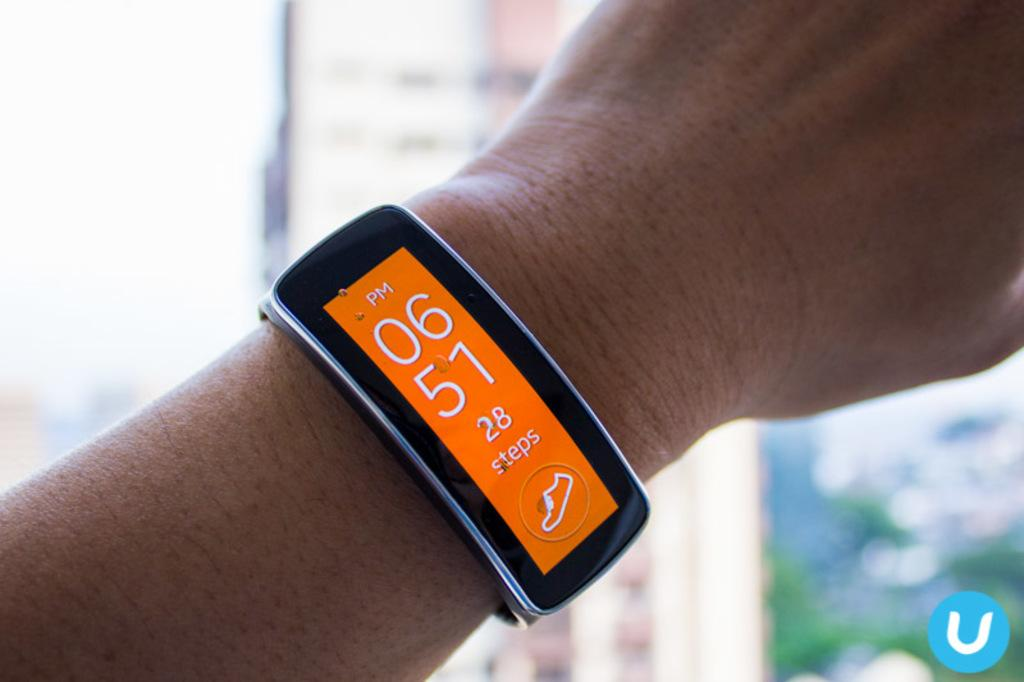<image>
Give a short and clear explanation of the subsequent image. Person wearing a wristwatch which says 0651 on it. 